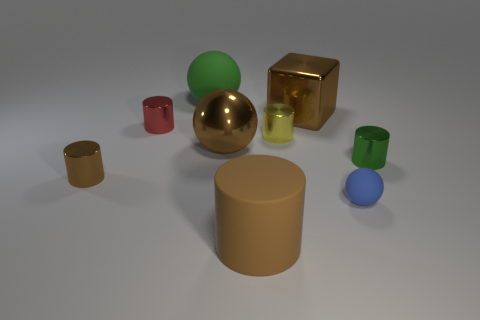There is a blue object that is the same shape as the big green rubber object; what is its material?
Your answer should be compact. Rubber. Is the material of the blue thing the same as the small green cylinder?
Give a very brief answer. No. Are there more brown rubber cylinders in front of the green rubber thing than tiny green shiny objects?
Provide a short and direct response. No. What material is the small red cylinder in front of the green object that is behind the tiny metal thing right of the large block?
Your answer should be very brief. Metal. What number of things are either large rubber spheres or brown cylinders in front of the large metallic cube?
Provide a succinct answer. 3. There is a rubber thing that is in front of the small matte ball; does it have the same color as the small rubber object?
Your answer should be very brief. No. Is the number of big metallic objects in front of the red cylinder greater than the number of large shiny cubes in front of the green cylinder?
Ensure brevity in your answer.  Yes. Are there any other things that are the same color as the metallic sphere?
Provide a succinct answer. Yes. How many objects are either tiny matte balls or blue shiny spheres?
Your answer should be very brief. 1. Is the size of the brown metal object that is to the right of the rubber cylinder the same as the tiny yellow thing?
Your response must be concise. No. 